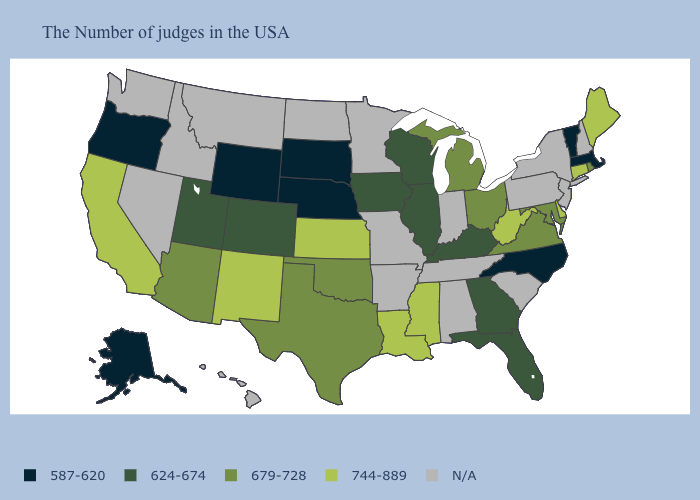What is the highest value in the USA?
Answer briefly. 744-889. Which states have the highest value in the USA?
Concise answer only. Maine, Connecticut, Delaware, West Virginia, Mississippi, Louisiana, Kansas, New Mexico, California. What is the lowest value in the West?
Quick response, please. 587-620. Does South Dakota have the lowest value in the MidWest?
Be succinct. Yes. Name the states that have a value in the range N/A?
Keep it brief. New Hampshire, New York, New Jersey, Pennsylvania, South Carolina, Indiana, Alabama, Tennessee, Missouri, Arkansas, Minnesota, North Dakota, Montana, Idaho, Nevada, Washington, Hawaii. What is the value of Pennsylvania?
Write a very short answer. N/A. What is the value of Mississippi?
Give a very brief answer. 744-889. Name the states that have a value in the range N/A?
Answer briefly. New Hampshire, New York, New Jersey, Pennsylvania, South Carolina, Indiana, Alabama, Tennessee, Missouri, Arkansas, Minnesota, North Dakota, Montana, Idaho, Nevada, Washington, Hawaii. What is the lowest value in the Northeast?
Write a very short answer. 587-620. Name the states that have a value in the range 679-728?
Concise answer only. Rhode Island, Maryland, Virginia, Ohio, Michigan, Oklahoma, Texas, Arizona. Which states hav the highest value in the South?
Be succinct. Delaware, West Virginia, Mississippi, Louisiana. Which states hav the highest value in the South?
Give a very brief answer. Delaware, West Virginia, Mississippi, Louisiana. What is the value of Wyoming?
Quick response, please. 587-620. Does Florida have the lowest value in the South?
Keep it brief. No. 